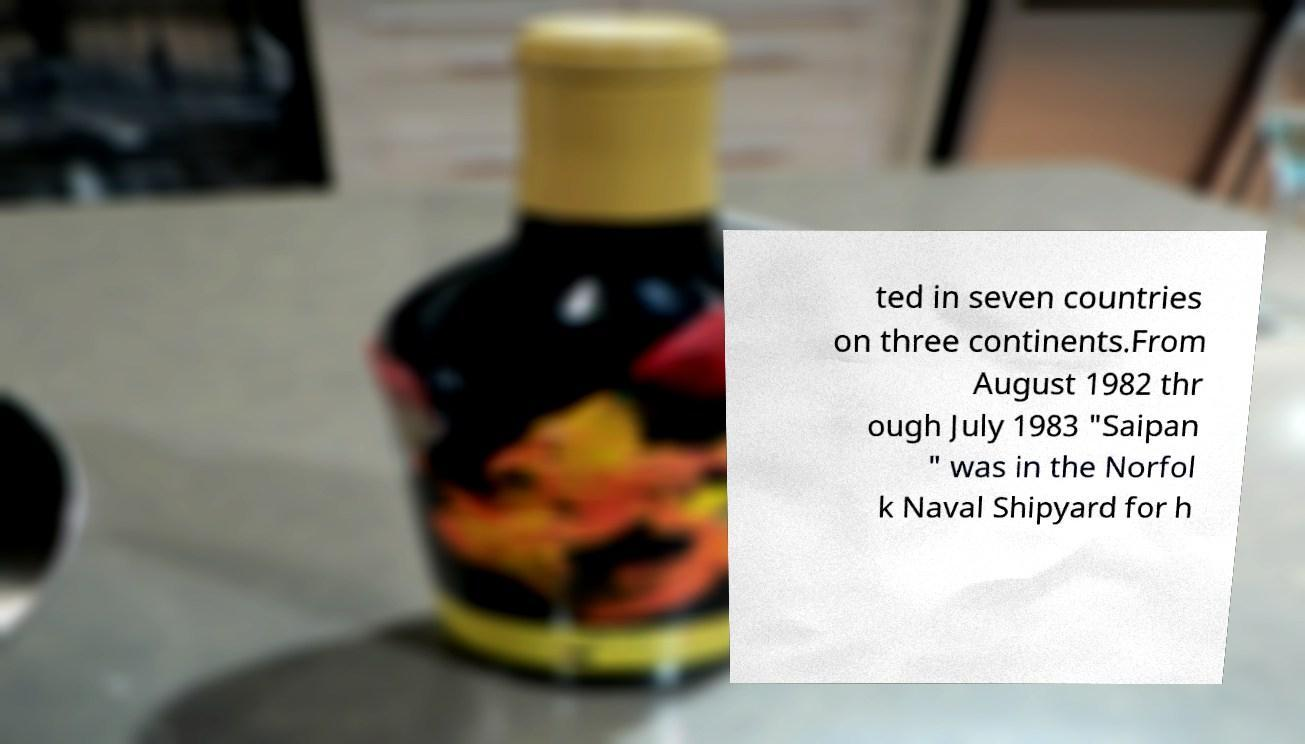What messages or text are displayed in this image? I need them in a readable, typed format. ted in seven countries on three continents.From August 1982 thr ough July 1983 "Saipan " was in the Norfol k Naval Shipyard for h 